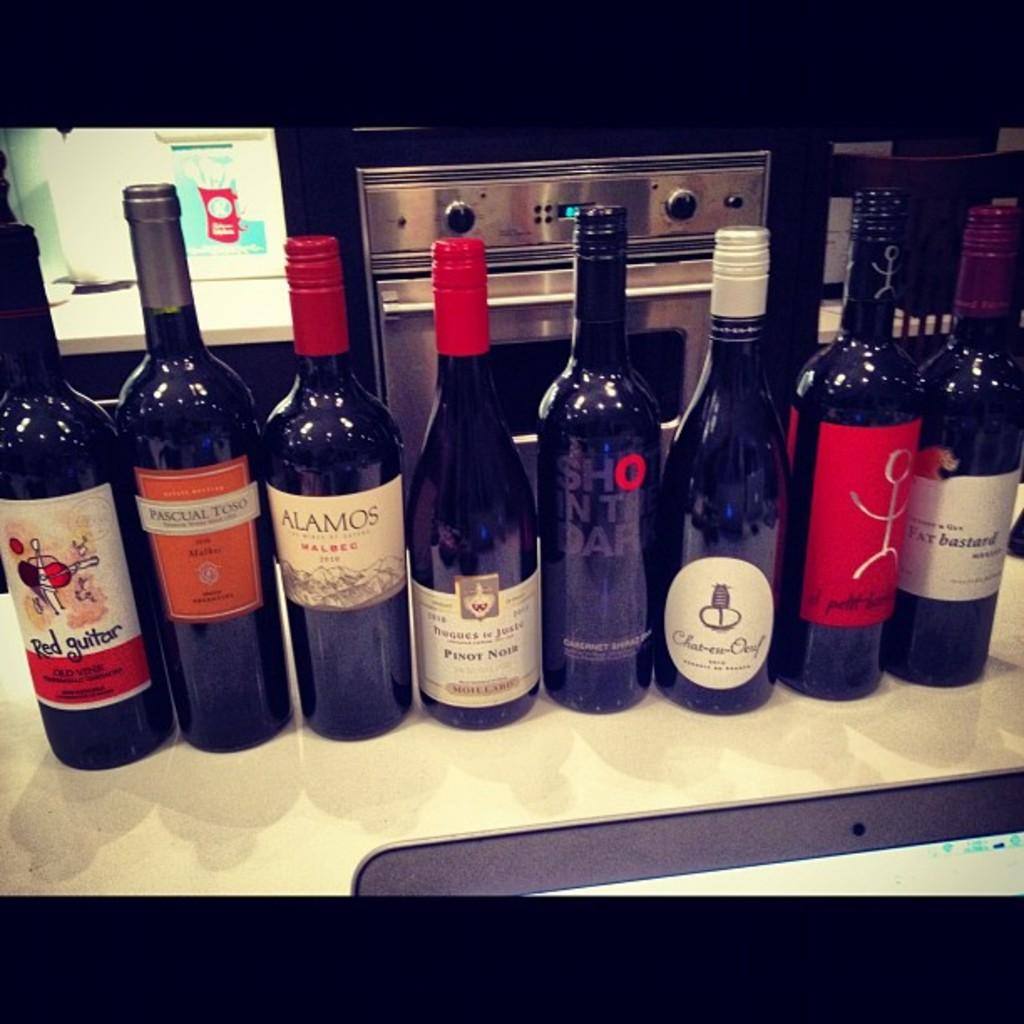<image>
Describe the image concisely. Multiple different wines from brands such as Red Guitar and Fat Bastard are lined up on a counter. 